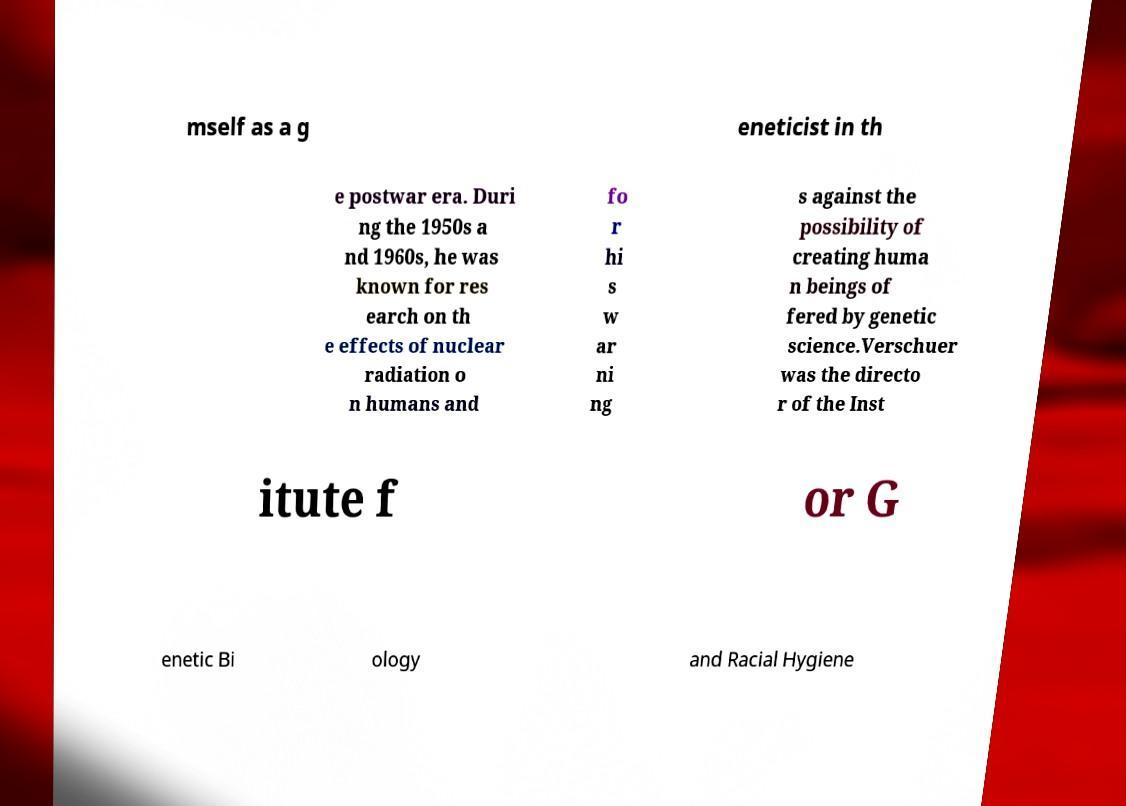Please identify and transcribe the text found in this image. mself as a g eneticist in th e postwar era. Duri ng the 1950s a nd 1960s, he was known for res earch on th e effects of nuclear radiation o n humans and fo r hi s w ar ni ng s against the possibility of creating huma n beings of fered by genetic science.Verschuer was the directo r of the Inst itute f or G enetic Bi ology and Racial Hygiene 